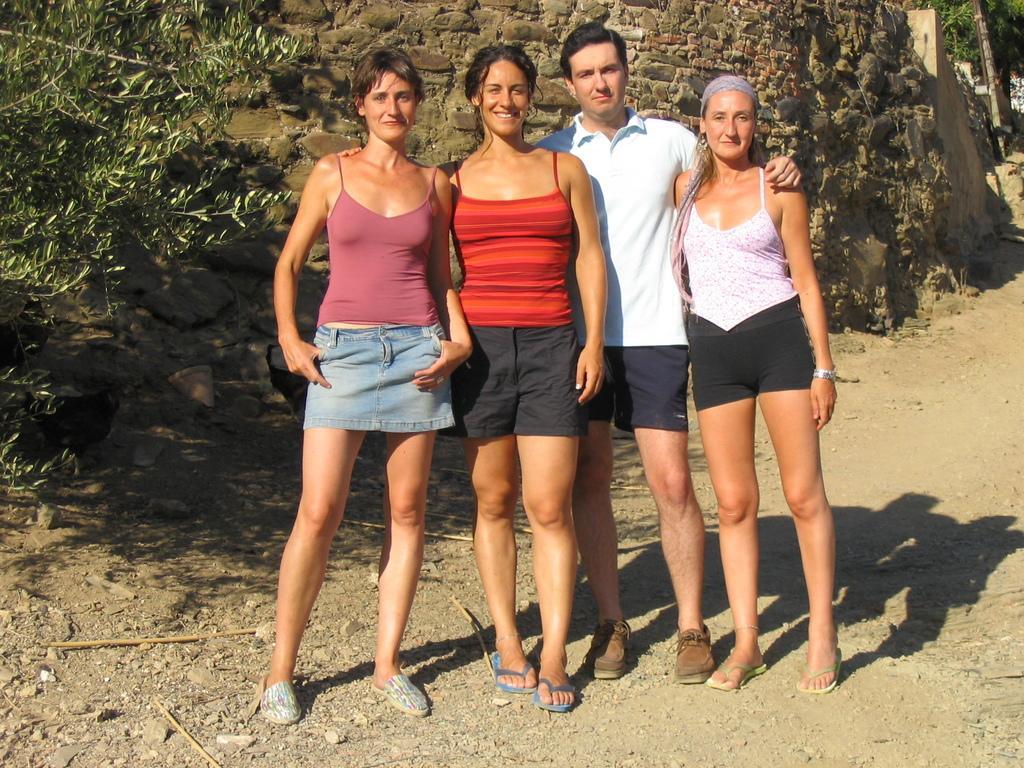Describe this image in one or two sentences. In the picture there are three women and a man standing on the ground, behind them there is a wall, there are trees. 